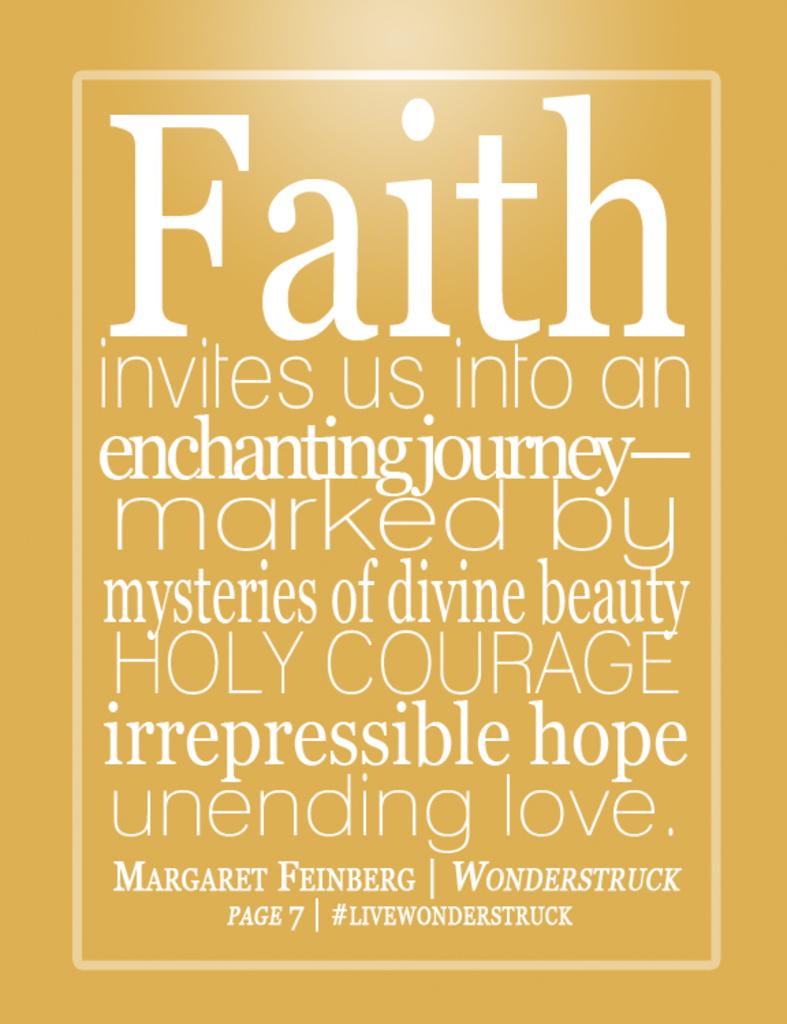Is is a front book cover or poster by margaret feinberg?
Offer a terse response. Yes. 